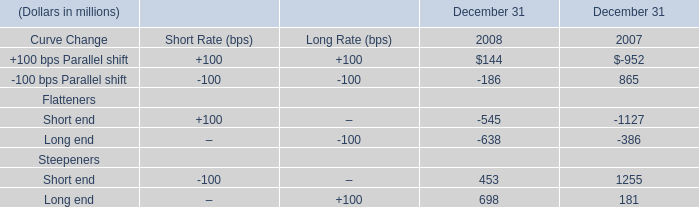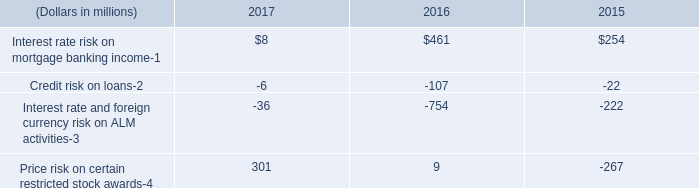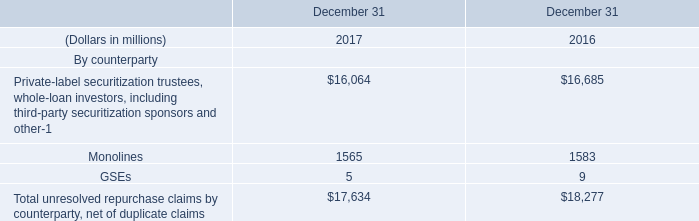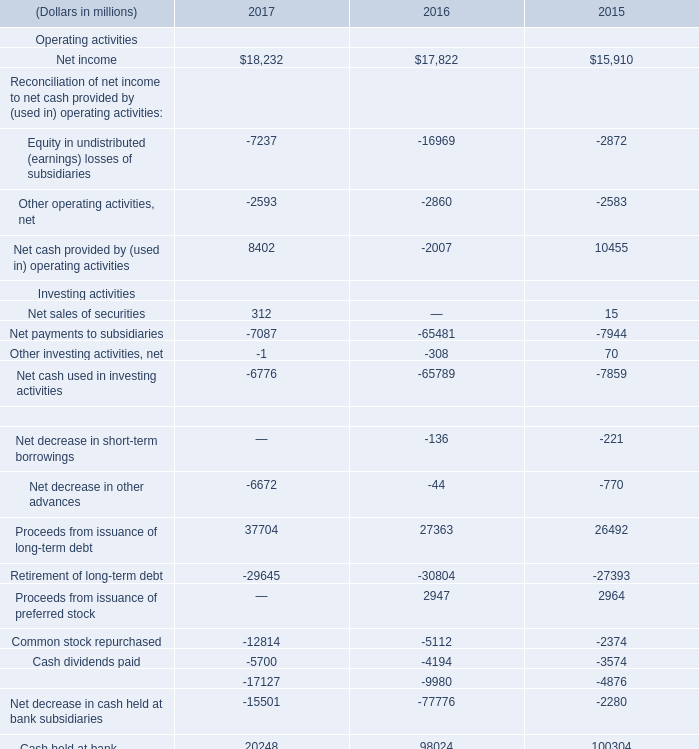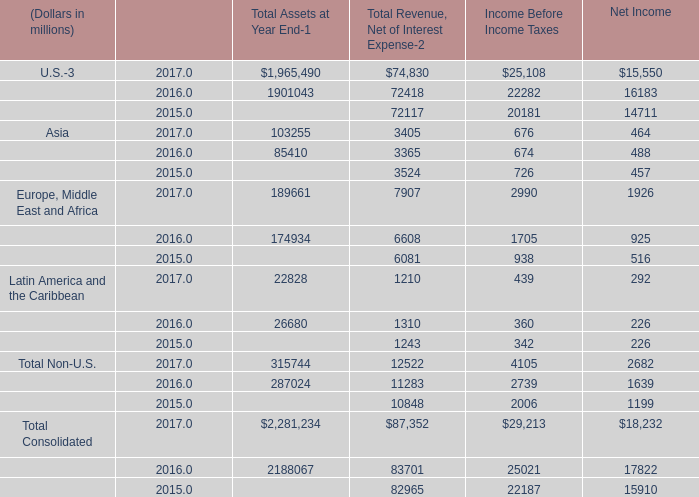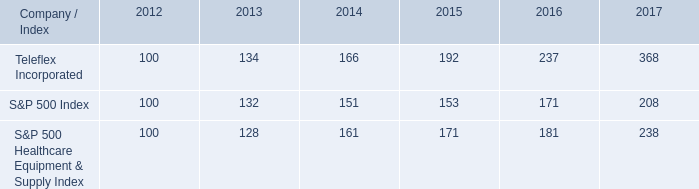What's the total amount of Investing activities excluding those negative ones in 2015? (in million) 
Computations: (15 + 70)
Answer: 85.0. 